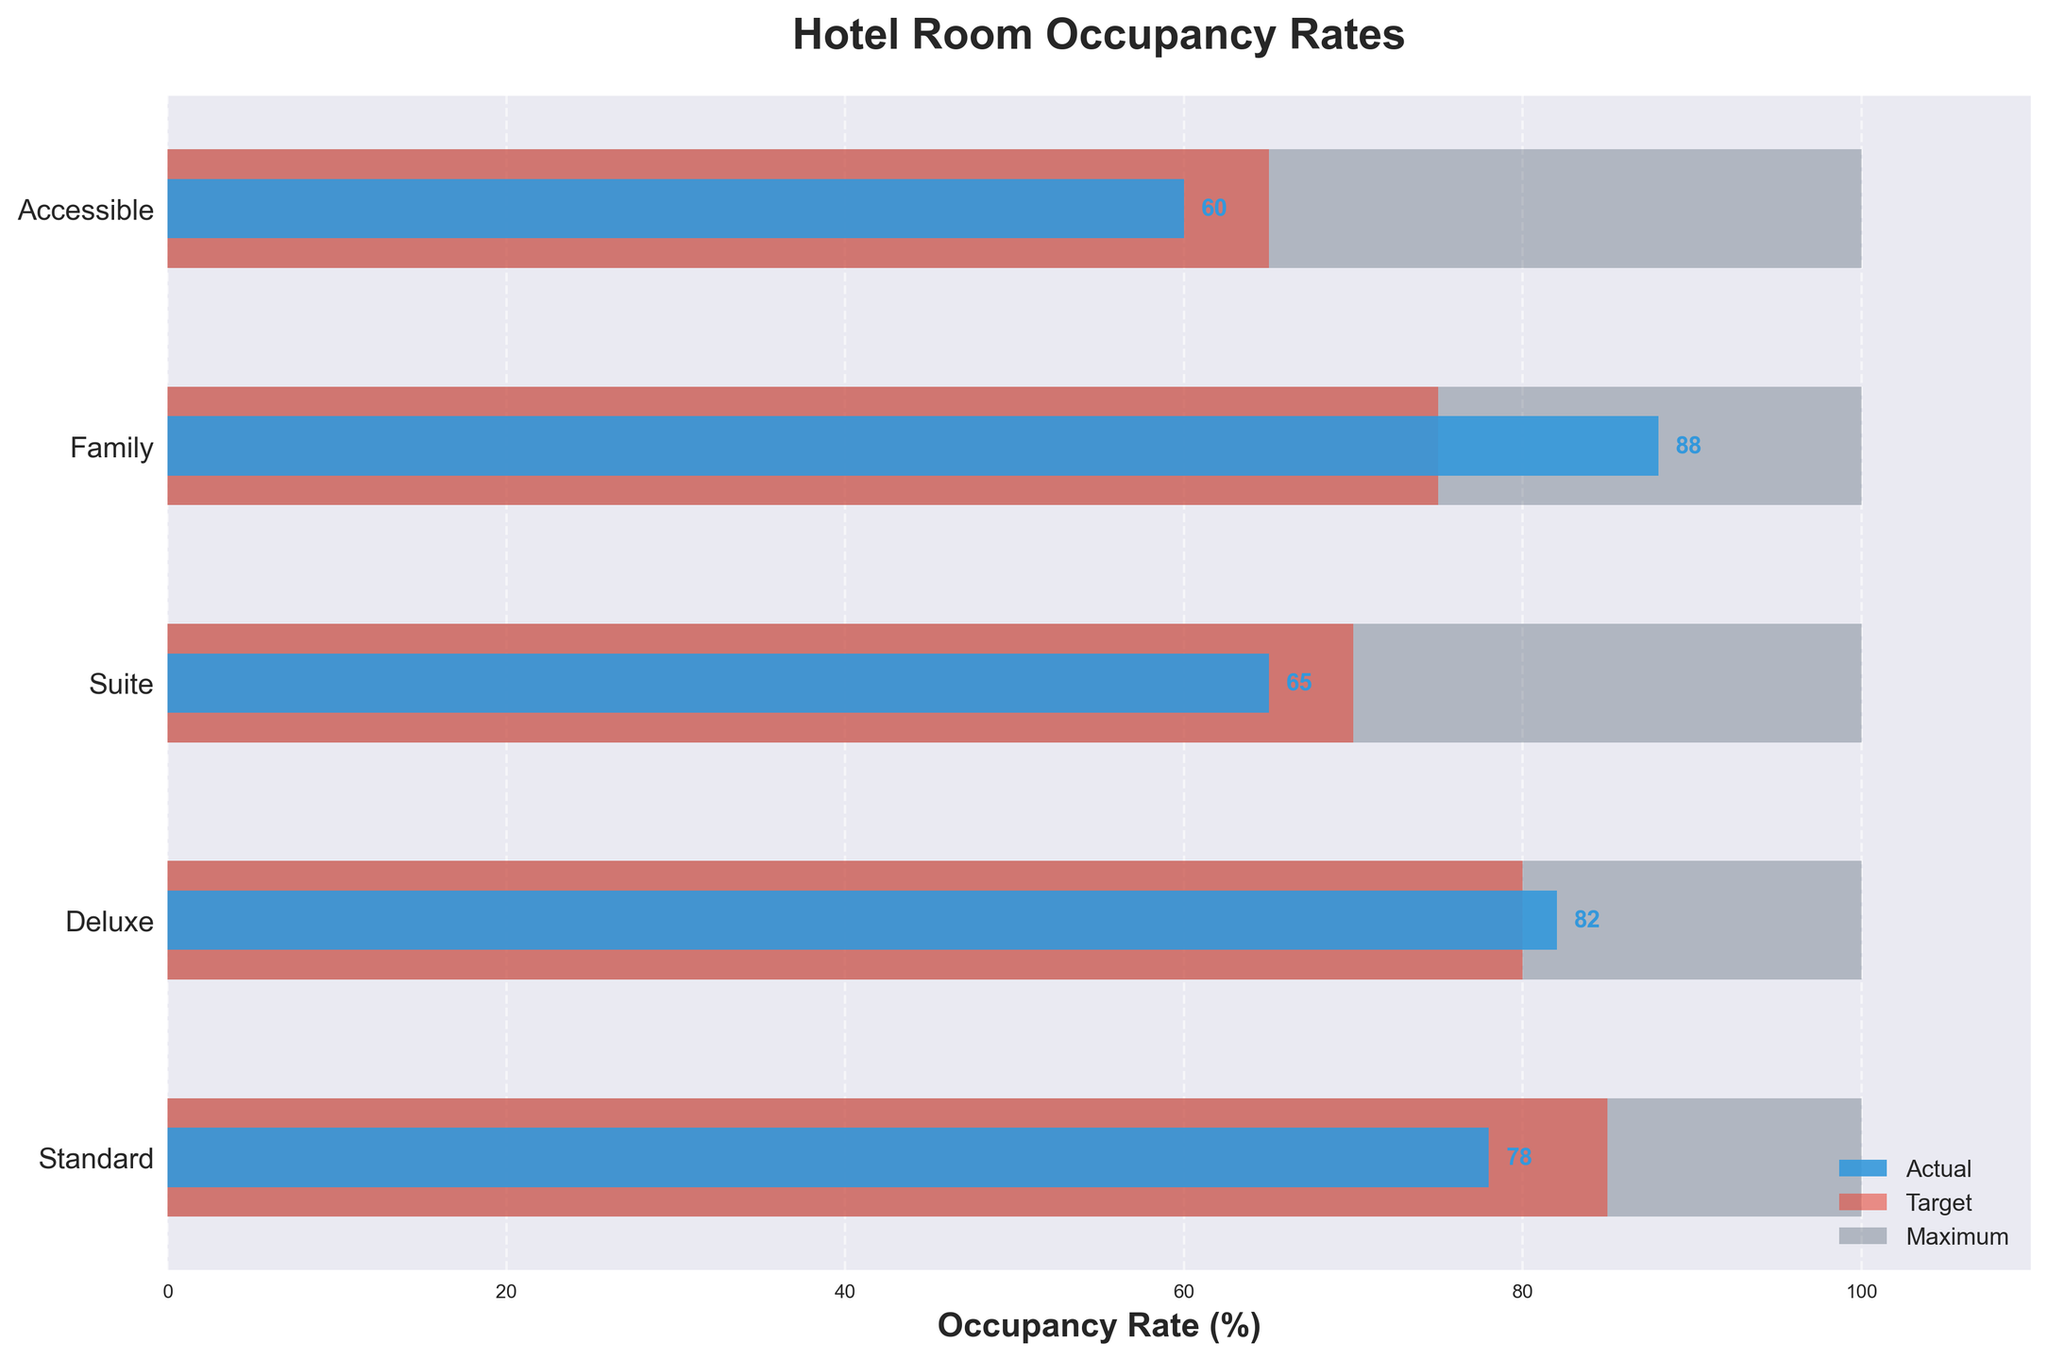What is the title of the figure? The title of the figure is written at the top and summarizes the main focus of the visual representation.
Answer: Hotel Room Occupancy Rates What are the room types displayed on the y-axis? The room types are listed on the y-axis as labels for each row of the chart.
Answer: Standard, Deluxe, Suite, Family, Accessible Which room type has the highest actual occupancy rate? By examining the lengths of the blue bars, we see that the 'Family' room type has the highest value.
Answer: Family What is the target occupancy rate for Suite rooms? The target occupancy rate is indicated by the length of the red bar for the 'Suite' room type.
Answer: 70% By how many percentage points did the Standard room type fall short of its target occupancy rate? Subtract the 'Actual Occupancy' percentage of the Standard room type from its 'Target Occupancy' percentage given in the bar lengths. 85% - 78% = 7%.
Answer: 7 percentage points Which room type exceeded its target occupancy rate and by how much? By comparing the blue and red bar lengths, the 'Deluxe' room type exceeded its target occupancy rate. Calculate the difference: 82% - 80% = 2%.
Answer: Deluxe, 2 percentage points What is the overall trend in actual occupancy compared to maximum capacity? The blue bars (actual occupancy) are significantly shorter than the gray bars (maximum capacity) for all room types, indicating that actual occupancy is generally below maximum capacity.
Answer: Lower than maximum capacity Which room type has the lowest actual occupancy rate? By examining the blue bars' lengths, we see that 'Accessible' has the shortest bar representing the lowest value.
Answer: Accessible What's the average actual occupancy rate across all room types? Add the actual occupancy rates for all room types and divide by the number of room types: (78% + 82% + 65% + 88% + 60%) / 5 = 74.6%.
Answer: 74.6% Is there any room type where actual occupancy equals the target occupancy rate? By comparing the blue and red bar lengths, we see that no room type has equal actual and target occupancy rates.
Answer: No 